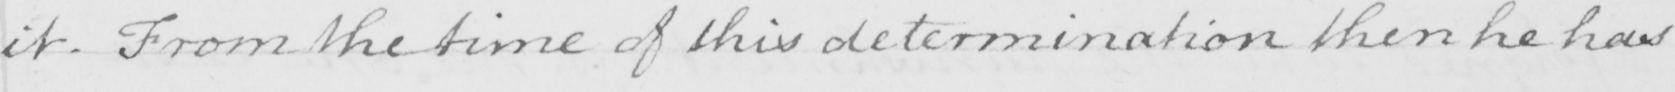What is written in this line of handwriting? it . From the time of this determination then he has 